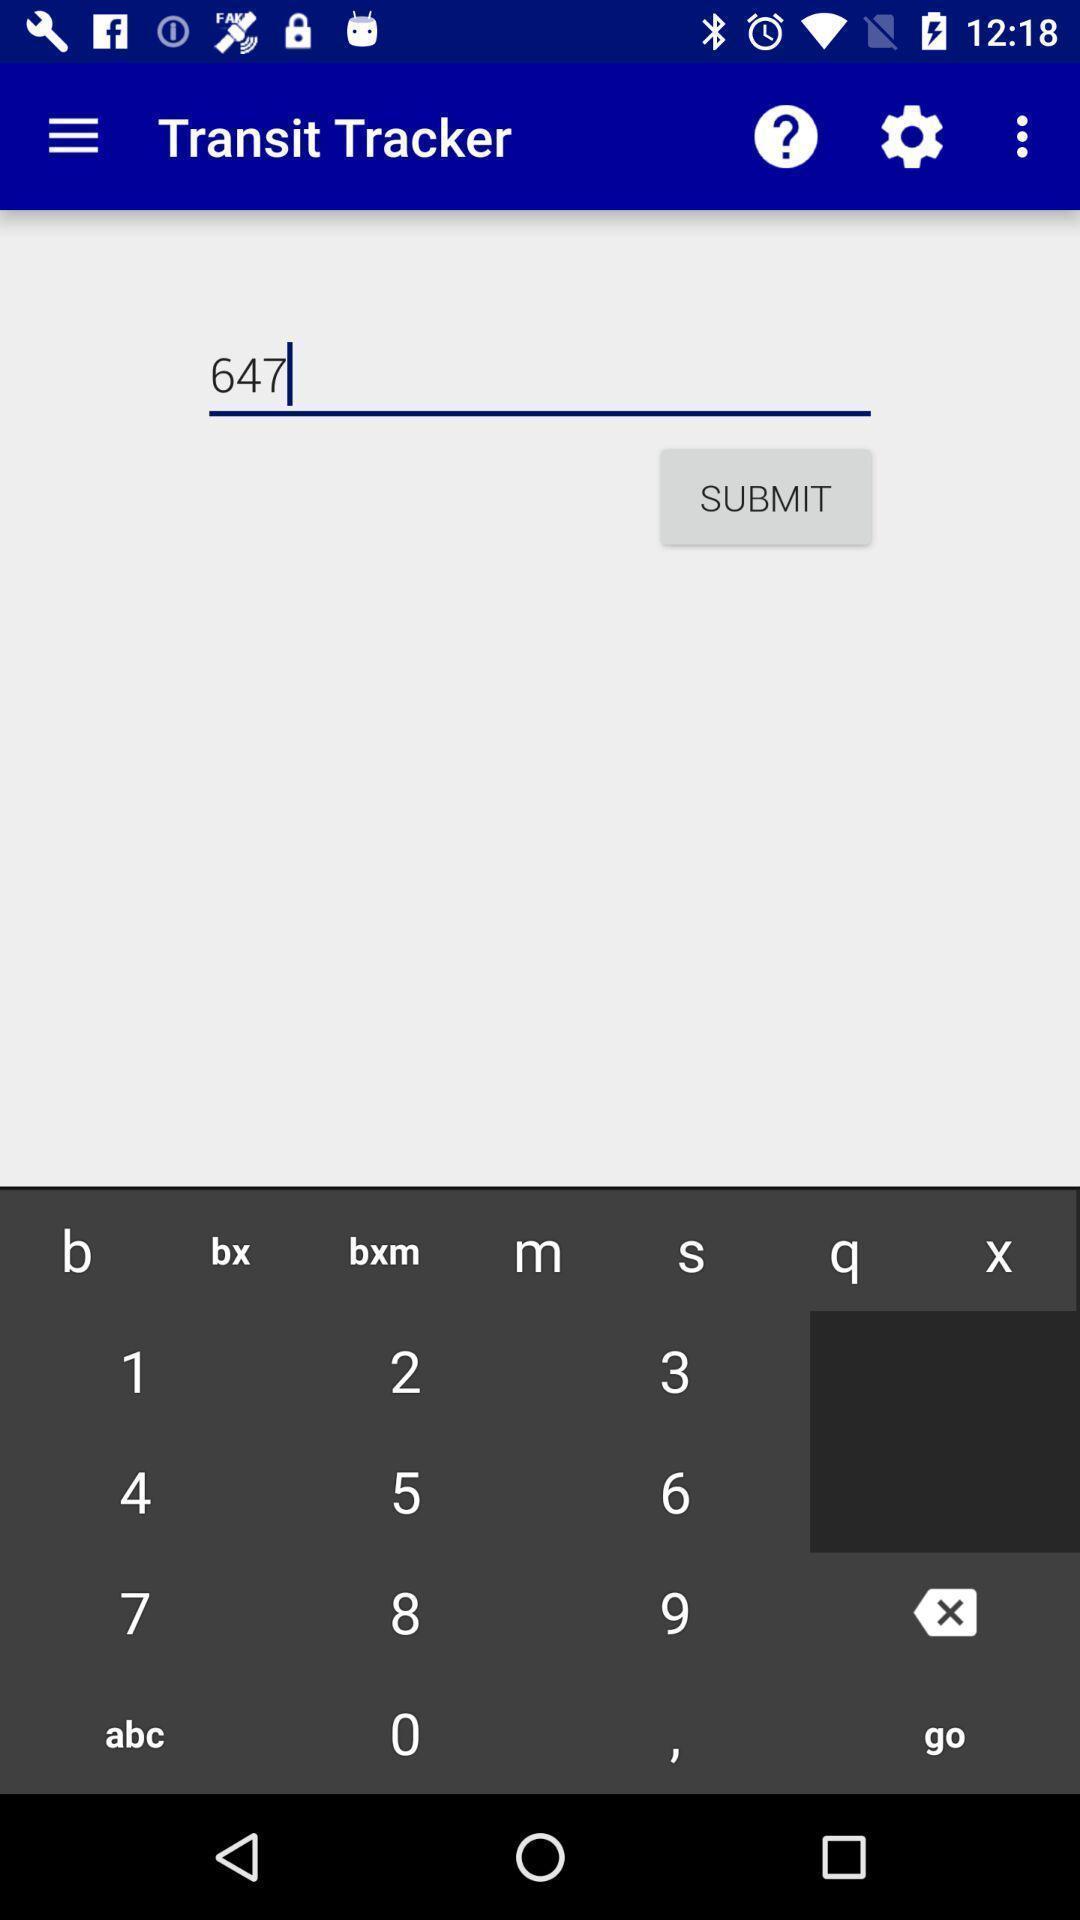Describe this image in words. Screen shows different options. 